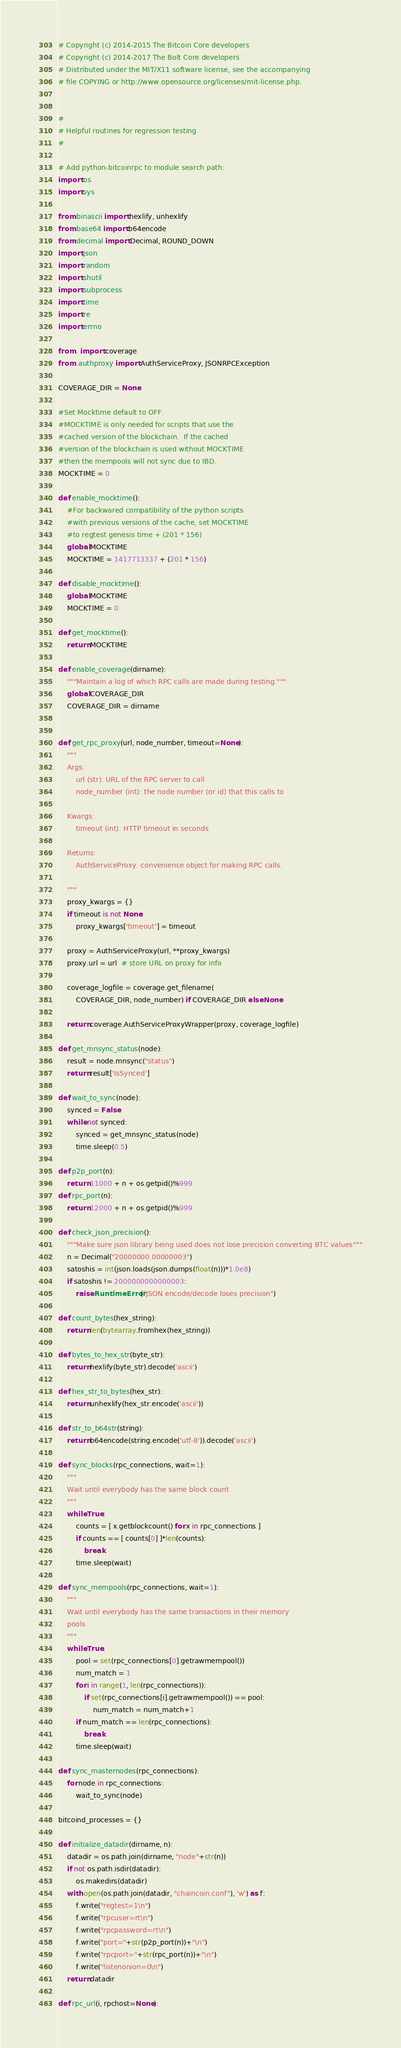<code> <loc_0><loc_0><loc_500><loc_500><_Python_># Copyright (c) 2014-2015 The Bitcoin Core developers
# Copyright (c) 2014-2017 The Bolt Core developers
# Distributed under the MIT/X11 software license, see the accompanying
# file COPYING or http://www.opensource.org/licenses/mit-license.php.


#
# Helpful routines for regression testing
#

# Add python-bitcoinrpc to module search path:
import os
import sys

from binascii import hexlify, unhexlify
from base64 import b64encode
from decimal import Decimal, ROUND_DOWN
import json
import random
import shutil
import subprocess
import time
import re
import errno

from . import coverage
from .authproxy import AuthServiceProxy, JSONRPCException

COVERAGE_DIR = None

#Set Mocktime default to OFF.
#MOCKTIME is only needed for scripts that use the
#cached version of the blockchain.  If the cached
#version of the blockchain is used without MOCKTIME
#then the mempools will not sync due to IBD.
MOCKTIME = 0

def enable_mocktime():
    #For backwared compatibility of the python scripts
    #with previous versions of the cache, set MOCKTIME 
    #to regtest genesis time + (201 * 156)
    global MOCKTIME
    MOCKTIME = 1417713337 + (201 * 156)

def disable_mocktime():
    global MOCKTIME
    MOCKTIME = 0

def get_mocktime():
    return MOCKTIME

def enable_coverage(dirname):
    """Maintain a log of which RPC calls are made during testing."""
    global COVERAGE_DIR
    COVERAGE_DIR = dirname


def get_rpc_proxy(url, node_number, timeout=None):
    """
    Args:
        url (str): URL of the RPC server to call
        node_number (int): the node number (or id) that this calls to

    Kwargs:
        timeout (int): HTTP timeout in seconds

    Returns:
        AuthServiceProxy. convenience object for making RPC calls.

    """
    proxy_kwargs = {}
    if timeout is not None:
        proxy_kwargs['timeout'] = timeout

    proxy = AuthServiceProxy(url, **proxy_kwargs)
    proxy.url = url  # store URL on proxy for info

    coverage_logfile = coverage.get_filename(
        COVERAGE_DIR, node_number) if COVERAGE_DIR else None

    return coverage.AuthServiceProxyWrapper(proxy, coverage_logfile)

def get_mnsync_status(node):
    result = node.mnsync("status")
    return result['IsSynced']

def wait_to_sync(node):
    synced = False
    while not synced:
        synced = get_mnsync_status(node)
        time.sleep(0.5)

def p2p_port(n):
    return 11000 + n + os.getpid()%999
def rpc_port(n):
    return 12000 + n + os.getpid()%999

def check_json_precision():
    """Make sure json library being used does not lose precision converting BTC values"""
    n = Decimal("20000000.00000003")
    satoshis = int(json.loads(json.dumps(float(n)))*1.0e8)
    if satoshis != 2000000000000003:
        raise RuntimeError("JSON encode/decode loses precision")

def count_bytes(hex_string):
    return len(bytearray.fromhex(hex_string))

def bytes_to_hex_str(byte_str):
    return hexlify(byte_str).decode('ascii')

def hex_str_to_bytes(hex_str):
    return unhexlify(hex_str.encode('ascii'))

def str_to_b64str(string):
    return b64encode(string.encode('utf-8')).decode('ascii')

def sync_blocks(rpc_connections, wait=1):
    """
    Wait until everybody has the same block count
    """
    while True:
        counts = [ x.getblockcount() for x in rpc_connections ]
        if counts == [ counts[0] ]*len(counts):
            break
        time.sleep(wait)

def sync_mempools(rpc_connections, wait=1):
    """
    Wait until everybody has the same transactions in their memory
    pools
    """
    while True:
        pool = set(rpc_connections[0].getrawmempool())
        num_match = 1
        for i in range(1, len(rpc_connections)):
            if set(rpc_connections[i].getrawmempool()) == pool:
                num_match = num_match+1
        if num_match == len(rpc_connections):
            break
        time.sleep(wait)

def sync_masternodes(rpc_connections):
    for node in rpc_connections:
        wait_to_sync(node)

bitcoind_processes = {}

def initialize_datadir(dirname, n):
    datadir = os.path.join(dirname, "node"+str(n))
    if not os.path.isdir(datadir):
        os.makedirs(datadir)
    with open(os.path.join(datadir, "chaincoin.conf"), 'w') as f:
        f.write("regtest=1\n")
        f.write("rpcuser=rt\n")
        f.write("rpcpassword=rt\n")
        f.write("port="+str(p2p_port(n))+"\n")
        f.write("rpcport="+str(rpc_port(n))+"\n")
        f.write("listenonion=0\n")
    return datadir

def rpc_url(i, rpchost=None):</code> 